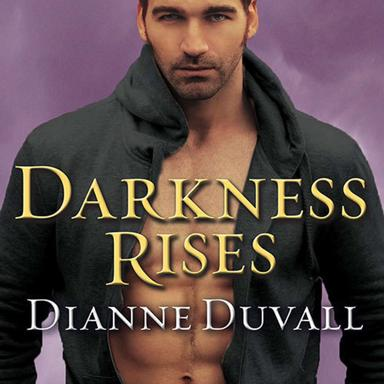What genre does "Darkness Rises" fall under? "Darkness Rises," penned by Dianne Duvall, falls under the genre of paranormal romance. This novel intricately weaves romantic elements with the mysterious and supernatural, offering readers an escape into a world of fantasy and intrigue. 